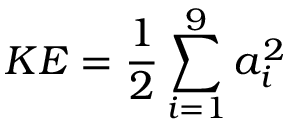<formula> <loc_0><loc_0><loc_500><loc_500>K E = \frac { 1 } { 2 } \sum _ { i = 1 } ^ { 9 } a _ { i } ^ { 2 }</formula> 